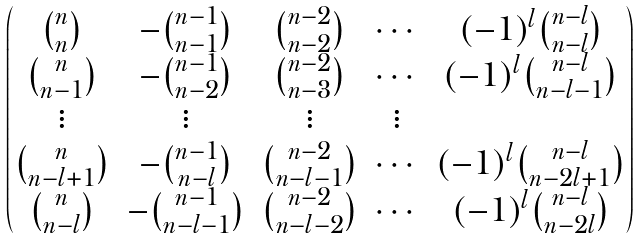<formula> <loc_0><loc_0><loc_500><loc_500>\begin{pmatrix} \binom { n } { n } & - \binom { n - 1 } { n - 1 } & \binom { n - 2 } { n - 2 } & \cdots & ( - 1 ) ^ { l } \binom { n - l } { n - l } \\ \binom { n } { n - 1 } & - \binom { n - 1 } { n - 2 } & \binom { n - 2 } { n - 3 } & \cdots & ( - 1 ) ^ { l } \binom { n - l } { n - l - 1 } \\ \vdots & \vdots & \vdots & \vdots \\ \binom { n } { n - l + 1 } & - \binom { n - 1 } { n - l } & \binom { n - 2 } { n - l - 1 } & \cdots & ( - 1 ) ^ { l } \binom { n - l } { n - 2 l + 1 } \\ \binom { n } { n - l } & - \binom { n - 1 } { n - l - 1 } & \binom { n - 2 } { n - l - 2 } & \cdots & ( - 1 ) ^ { l } \binom { n - l } { n - 2 l } \end{pmatrix}</formula> 